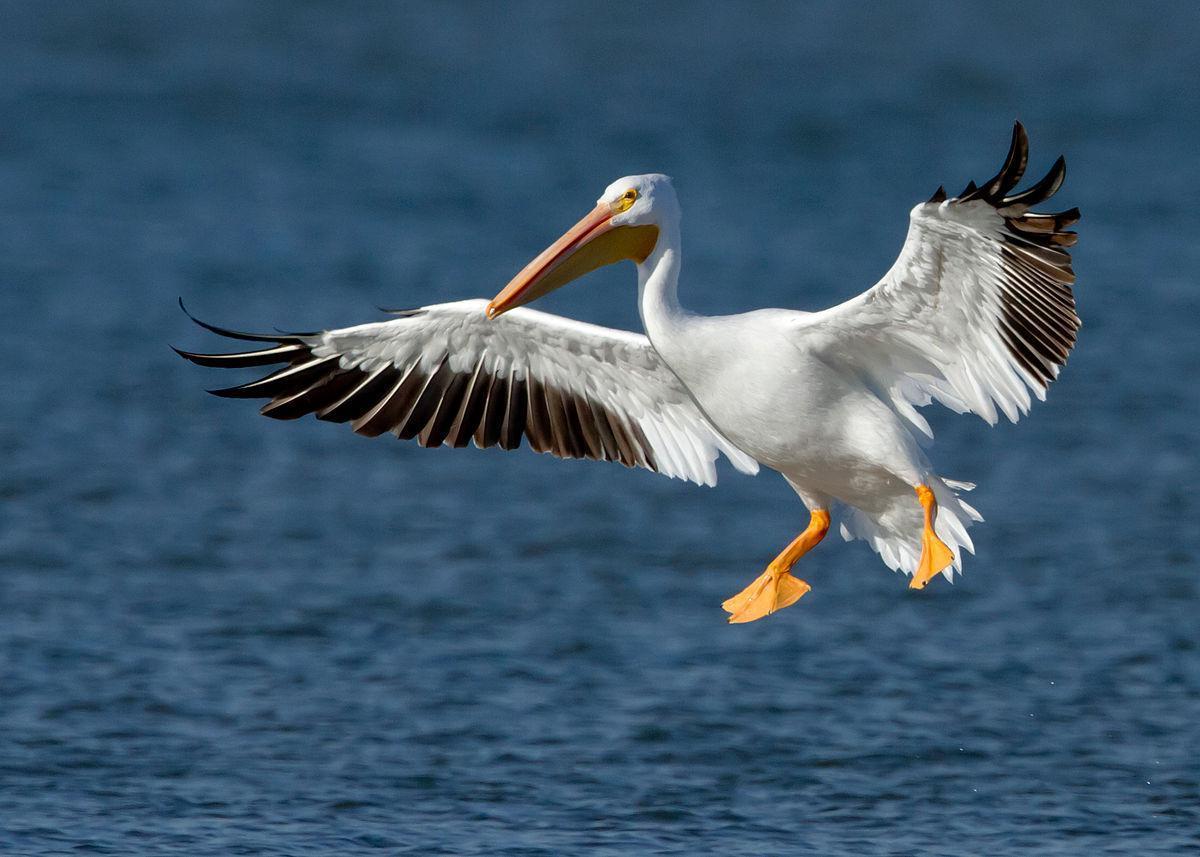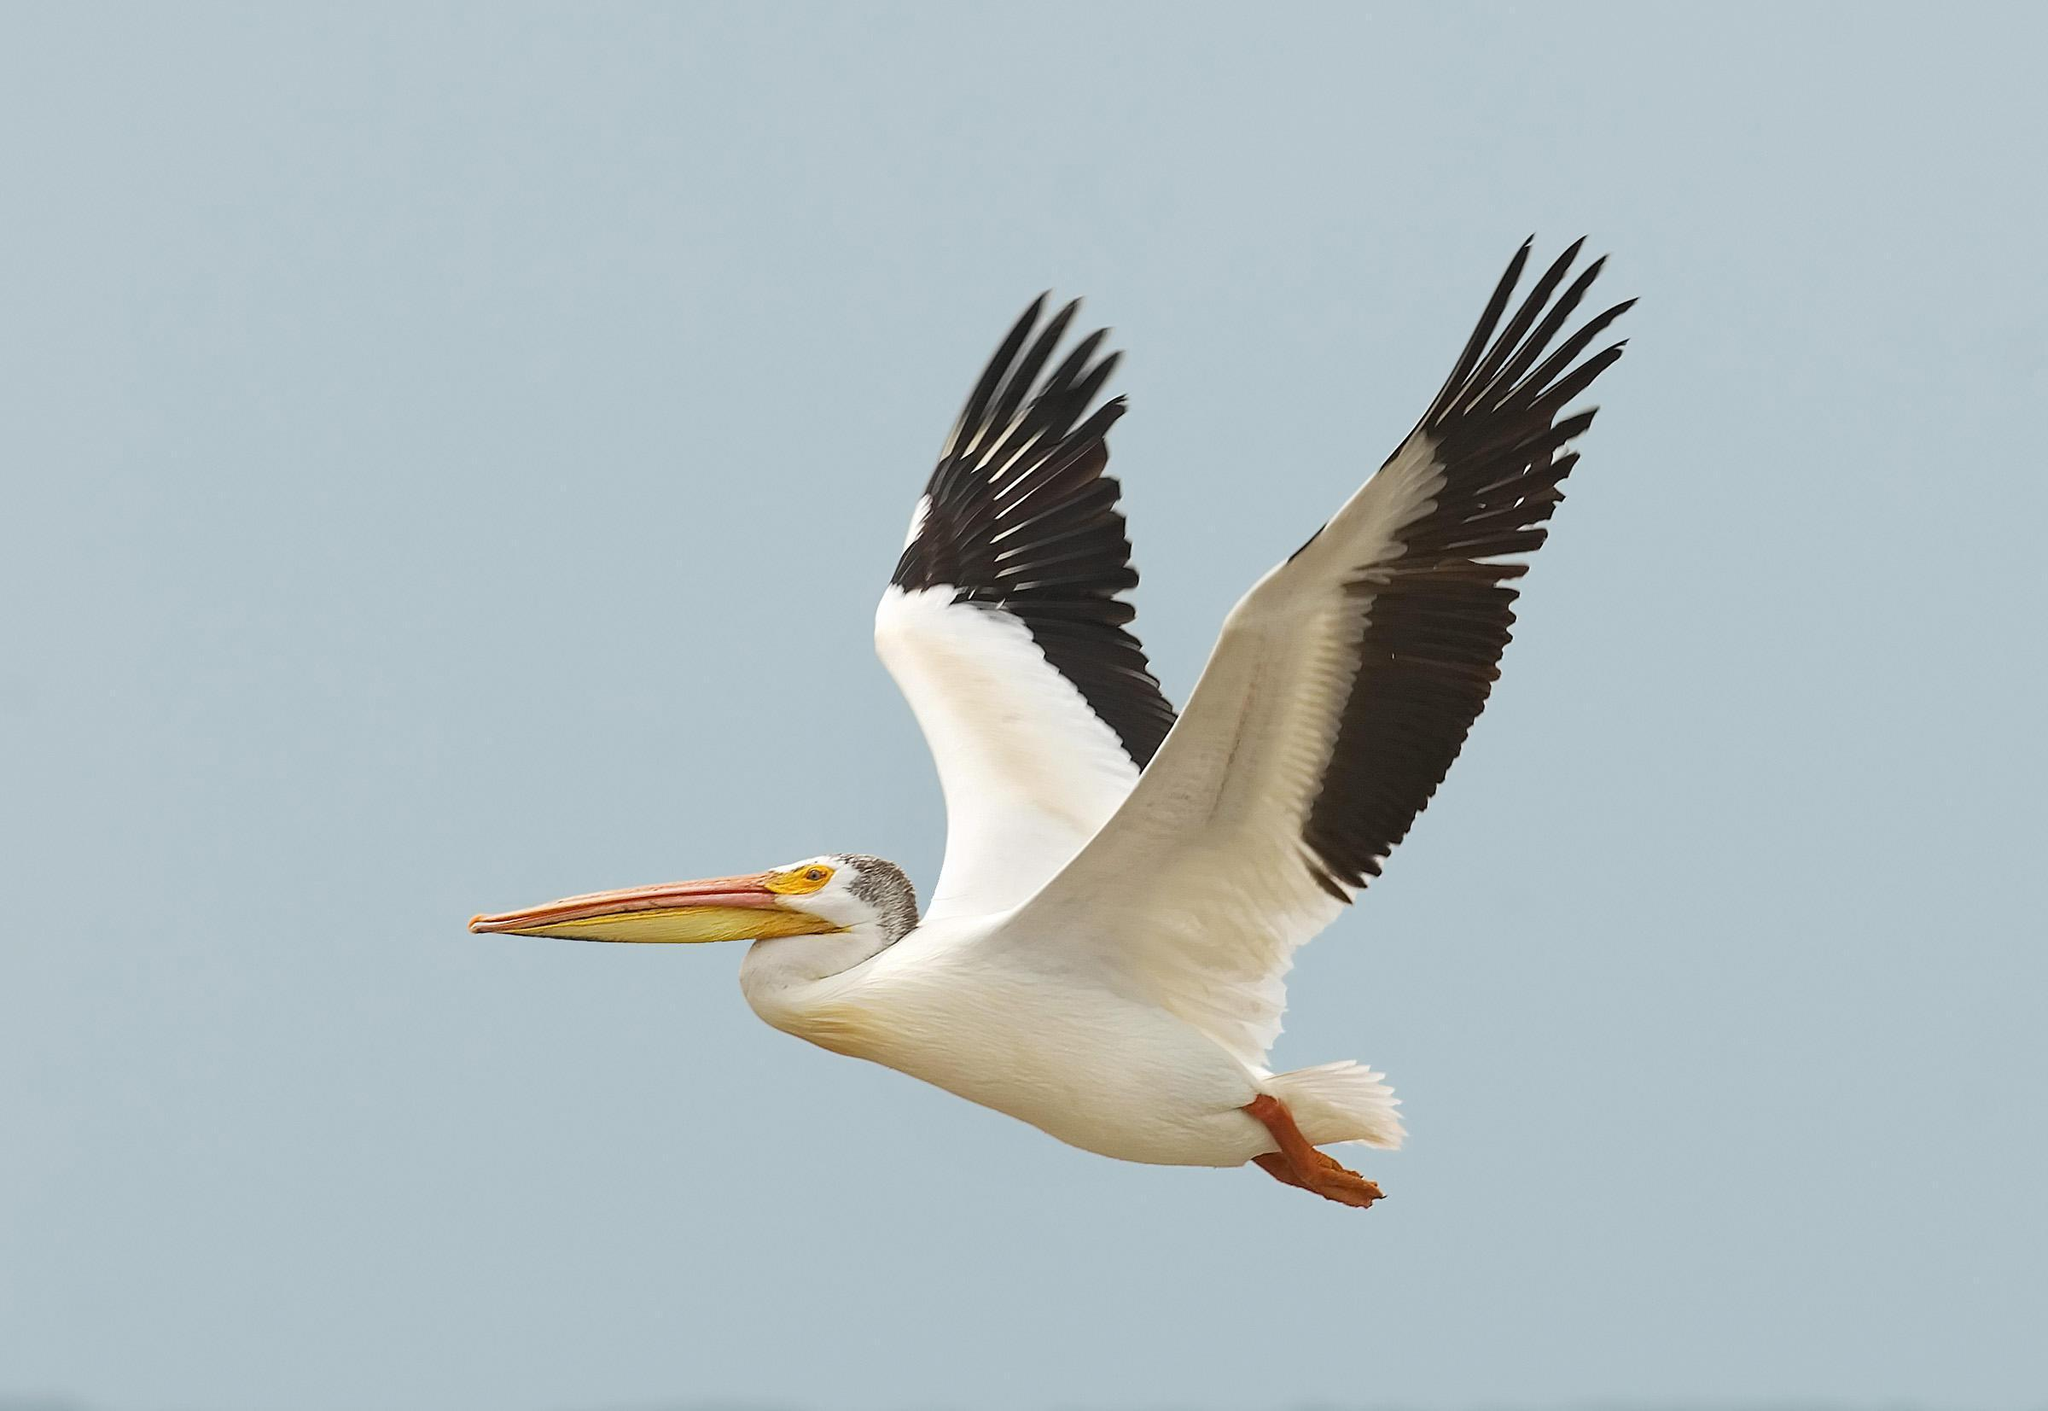The first image is the image on the left, the second image is the image on the right. Evaluate the accuracy of this statement regarding the images: "There are two pelicans flying". Is it true? Answer yes or no. Yes. 